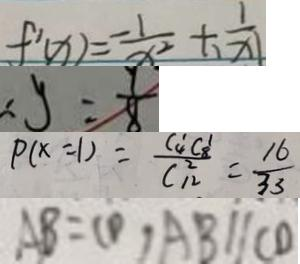Convert formula to latex. <formula><loc_0><loc_0><loc_500><loc_500>f ^ { \prime } ( x ) = \frac { - 1 } { x ^ { 2 } } + \frac { 1 } { \vert x \vert } 
 \therefore y = \frac { 9 } { 8 } 
 P ( x = 1 ) = \frac { C 4 ^ { 1 } C 8 ^ { 1 } } { C _ { 1 2 } ^ { 2 } } = \frac { 1 6 } { 3 3 } 
 A B = C D , A B / / C D</formula> 